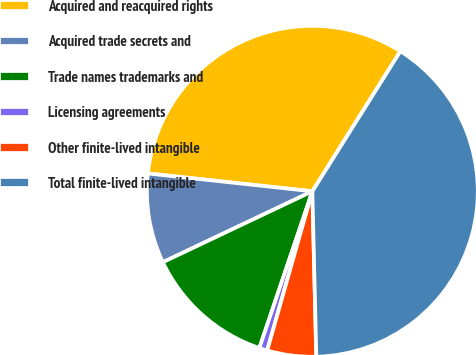<chart> <loc_0><loc_0><loc_500><loc_500><pie_chart><fcel>Acquired and reacquired rights<fcel>Acquired trade secrets and<fcel>Trade names trademarks and<fcel>Licensing agreements<fcel>Other finite-lived intangible<fcel>Total finite-lived intangible<nl><fcel>32.21%<fcel>8.77%<fcel>12.76%<fcel>0.79%<fcel>4.78%<fcel>40.69%<nl></chart> 